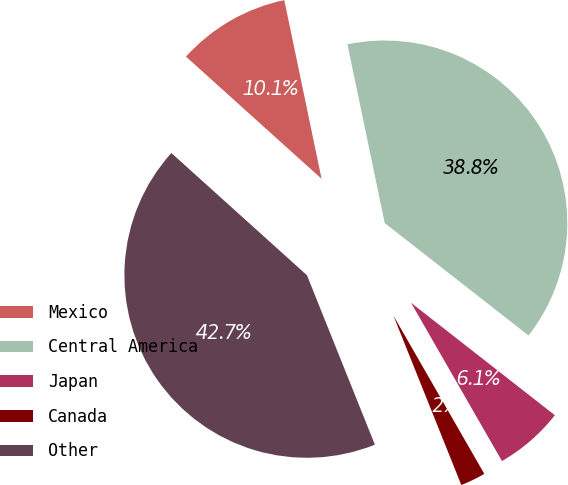<chart> <loc_0><loc_0><loc_500><loc_500><pie_chart><fcel>Mexico<fcel>Central America<fcel>Japan<fcel>Canada<fcel>Other<nl><fcel>10.05%<fcel>38.83%<fcel>6.14%<fcel>2.23%<fcel>42.74%<nl></chart> 